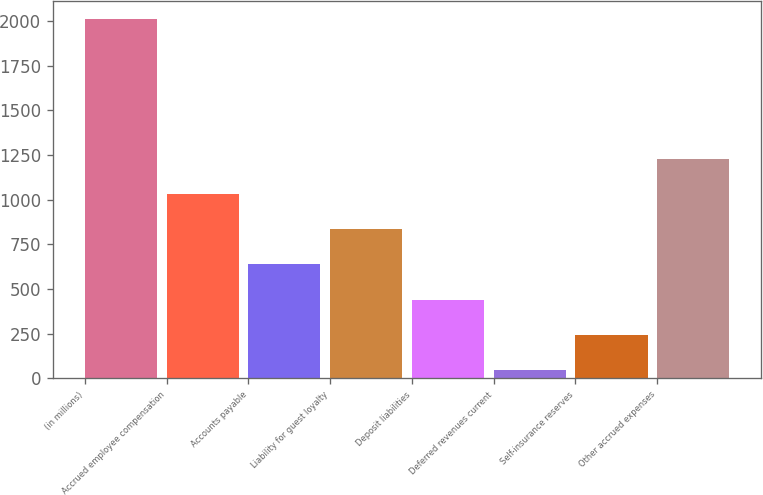<chart> <loc_0><loc_0><loc_500><loc_500><bar_chart><fcel>(in millions)<fcel>Accrued employee compensation<fcel>Accounts payable<fcel>Liability for guest loyalty<fcel>Deposit liabilities<fcel>Deferred revenues current<fcel>Self-insurance reserves<fcel>Other accrued expenses<nl><fcel>2013<fcel>1030.5<fcel>637.5<fcel>834<fcel>441<fcel>48<fcel>244.5<fcel>1227<nl></chart> 